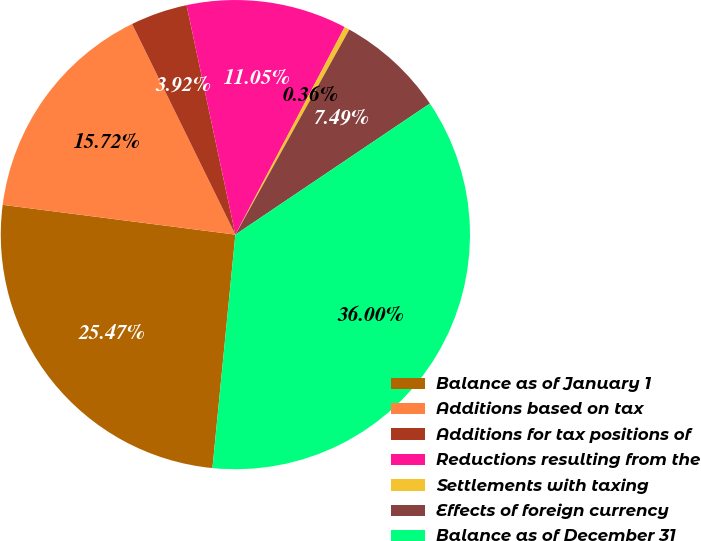<chart> <loc_0><loc_0><loc_500><loc_500><pie_chart><fcel>Balance as of January 1<fcel>Additions based on tax<fcel>Additions for tax positions of<fcel>Reductions resulting from the<fcel>Settlements with taxing<fcel>Effects of foreign currency<fcel>Balance as of December 31<nl><fcel>25.47%<fcel>15.72%<fcel>3.92%<fcel>11.05%<fcel>0.36%<fcel>7.49%<fcel>36.0%<nl></chart> 